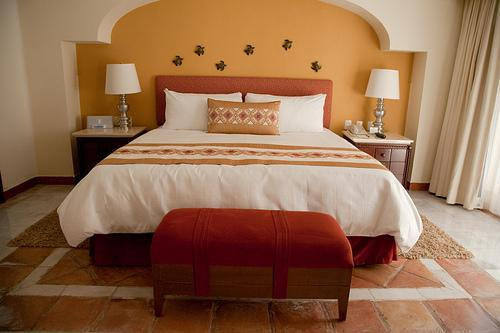Question: what are the three white and brown object on top of the bed?
Choices:
A. Pillows.
B. Blankets.
C. Clothes.
D. Cats.
Answer with the letter. Answer: A Question: where is the ceiling fan?
Choices:
A. There isn't one.
B. In the bedroom.
C. In the living room.
D. In the kitchen.
Answer with the letter. Answer: A 